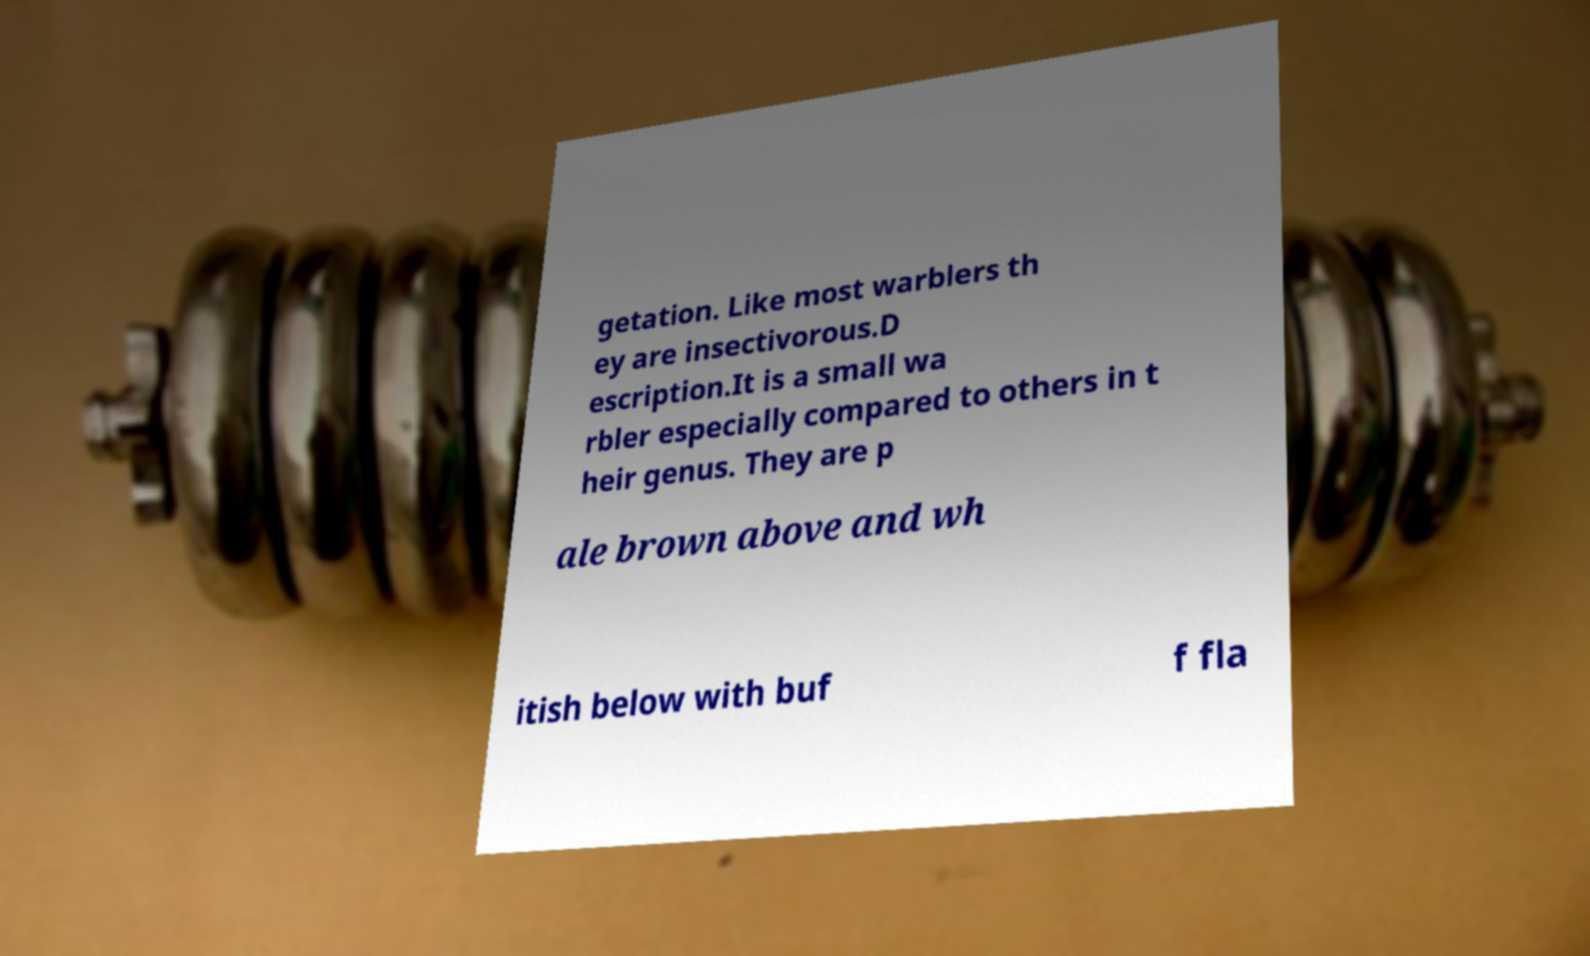What messages or text are displayed in this image? I need them in a readable, typed format. getation. Like most warblers th ey are insectivorous.D escription.It is a small wa rbler especially compared to others in t heir genus. They are p ale brown above and wh itish below with buf f fla 